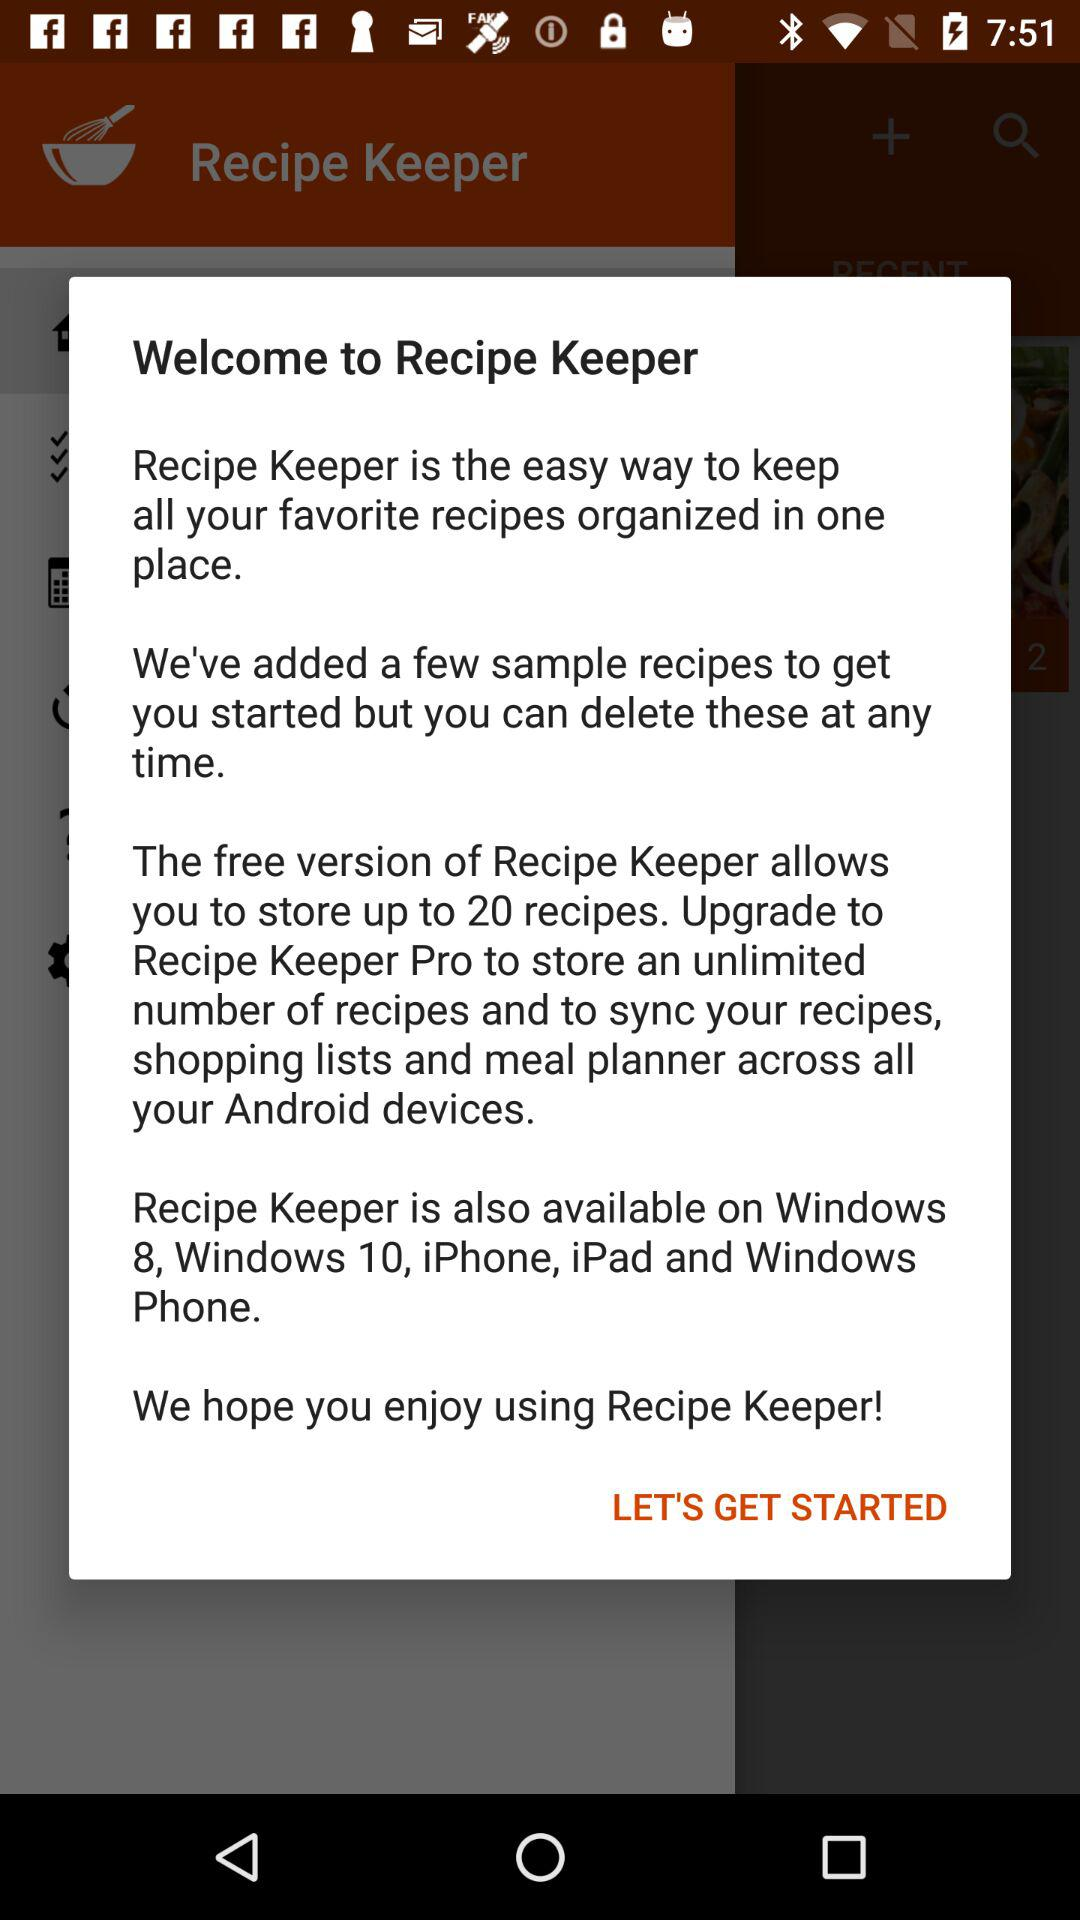What is the name of the application? The name of the application is "Recipe Keeper". 